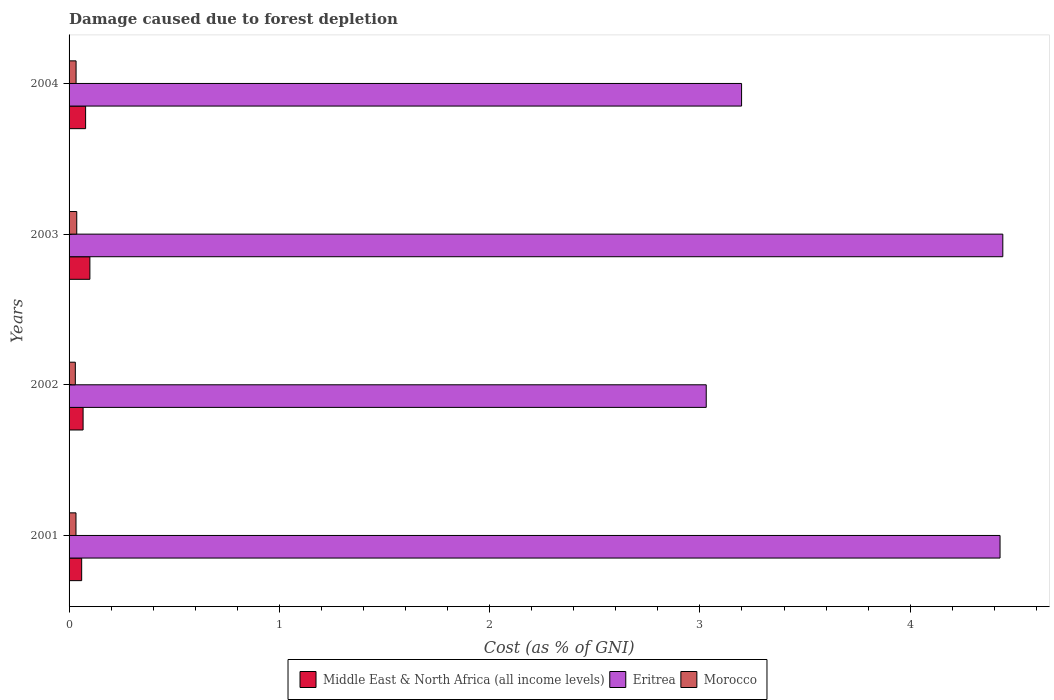How many groups of bars are there?
Offer a terse response. 4. Are the number of bars per tick equal to the number of legend labels?
Provide a succinct answer. Yes. How many bars are there on the 3rd tick from the top?
Offer a very short reply. 3. How many bars are there on the 4th tick from the bottom?
Give a very brief answer. 3. What is the cost of damage caused due to forest depletion in Eritrea in 2001?
Provide a short and direct response. 4.43. Across all years, what is the maximum cost of damage caused due to forest depletion in Eritrea?
Offer a very short reply. 4.44. Across all years, what is the minimum cost of damage caused due to forest depletion in Eritrea?
Offer a terse response. 3.03. In which year was the cost of damage caused due to forest depletion in Middle East & North Africa (all income levels) maximum?
Your response must be concise. 2003. What is the total cost of damage caused due to forest depletion in Middle East & North Africa (all income levels) in the graph?
Your response must be concise. 0.3. What is the difference between the cost of damage caused due to forest depletion in Middle East & North Africa (all income levels) in 2001 and that in 2004?
Provide a short and direct response. -0.02. What is the difference between the cost of damage caused due to forest depletion in Morocco in 2004 and the cost of damage caused due to forest depletion in Middle East & North Africa (all income levels) in 2002?
Provide a short and direct response. -0.03. What is the average cost of damage caused due to forest depletion in Eritrea per year?
Your answer should be very brief. 3.77. In the year 2002, what is the difference between the cost of damage caused due to forest depletion in Eritrea and cost of damage caused due to forest depletion in Middle East & North Africa (all income levels)?
Ensure brevity in your answer.  2.96. In how many years, is the cost of damage caused due to forest depletion in Middle East & North Africa (all income levels) greater than 1.2 %?
Keep it short and to the point. 0. What is the ratio of the cost of damage caused due to forest depletion in Middle East & North Africa (all income levels) in 2002 to that in 2004?
Your answer should be compact. 0.85. Is the cost of damage caused due to forest depletion in Morocco in 2003 less than that in 2004?
Your response must be concise. No. What is the difference between the highest and the second highest cost of damage caused due to forest depletion in Eritrea?
Ensure brevity in your answer.  0.01. What is the difference between the highest and the lowest cost of damage caused due to forest depletion in Eritrea?
Ensure brevity in your answer.  1.41. Is the sum of the cost of damage caused due to forest depletion in Morocco in 2001 and 2003 greater than the maximum cost of damage caused due to forest depletion in Middle East & North Africa (all income levels) across all years?
Keep it short and to the point. No. What does the 2nd bar from the top in 2001 represents?
Your answer should be very brief. Eritrea. What does the 1st bar from the bottom in 2001 represents?
Your answer should be very brief. Middle East & North Africa (all income levels). Is it the case that in every year, the sum of the cost of damage caused due to forest depletion in Eritrea and cost of damage caused due to forest depletion in Morocco is greater than the cost of damage caused due to forest depletion in Middle East & North Africa (all income levels)?
Provide a short and direct response. Yes. Are all the bars in the graph horizontal?
Provide a short and direct response. Yes. How many years are there in the graph?
Ensure brevity in your answer.  4. What is the difference between two consecutive major ticks on the X-axis?
Your answer should be compact. 1. How many legend labels are there?
Your answer should be very brief. 3. How are the legend labels stacked?
Offer a terse response. Horizontal. What is the title of the graph?
Offer a terse response. Damage caused due to forest depletion. Does "Seychelles" appear as one of the legend labels in the graph?
Ensure brevity in your answer.  No. What is the label or title of the X-axis?
Offer a terse response. Cost (as % of GNI). What is the Cost (as % of GNI) of Middle East & North Africa (all income levels) in 2001?
Ensure brevity in your answer.  0.06. What is the Cost (as % of GNI) in Eritrea in 2001?
Your answer should be compact. 4.43. What is the Cost (as % of GNI) of Morocco in 2001?
Keep it short and to the point. 0.03. What is the Cost (as % of GNI) of Middle East & North Africa (all income levels) in 2002?
Your response must be concise. 0.07. What is the Cost (as % of GNI) in Eritrea in 2002?
Give a very brief answer. 3.03. What is the Cost (as % of GNI) in Morocco in 2002?
Provide a short and direct response. 0.03. What is the Cost (as % of GNI) of Middle East & North Africa (all income levels) in 2003?
Provide a succinct answer. 0.1. What is the Cost (as % of GNI) of Eritrea in 2003?
Offer a terse response. 4.44. What is the Cost (as % of GNI) of Morocco in 2003?
Make the answer very short. 0.04. What is the Cost (as % of GNI) of Middle East & North Africa (all income levels) in 2004?
Your response must be concise. 0.08. What is the Cost (as % of GNI) in Eritrea in 2004?
Your response must be concise. 3.2. What is the Cost (as % of GNI) of Morocco in 2004?
Provide a short and direct response. 0.03. Across all years, what is the maximum Cost (as % of GNI) of Middle East & North Africa (all income levels)?
Make the answer very short. 0.1. Across all years, what is the maximum Cost (as % of GNI) of Eritrea?
Provide a short and direct response. 4.44. Across all years, what is the maximum Cost (as % of GNI) of Morocco?
Offer a terse response. 0.04. Across all years, what is the minimum Cost (as % of GNI) in Middle East & North Africa (all income levels)?
Offer a very short reply. 0.06. Across all years, what is the minimum Cost (as % of GNI) in Eritrea?
Keep it short and to the point. 3.03. Across all years, what is the minimum Cost (as % of GNI) in Morocco?
Provide a succinct answer. 0.03. What is the total Cost (as % of GNI) of Middle East & North Africa (all income levels) in the graph?
Offer a very short reply. 0.3. What is the total Cost (as % of GNI) of Eritrea in the graph?
Give a very brief answer. 15.1. What is the total Cost (as % of GNI) of Morocco in the graph?
Provide a succinct answer. 0.13. What is the difference between the Cost (as % of GNI) of Middle East & North Africa (all income levels) in 2001 and that in 2002?
Offer a very short reply. -0.01. What is the difference between the Cost (as % of GNI) in Eritrea in 2001 and that in 2002?
Ensure brevity in your answer.  1.4. What is the difference between the Cost (as % of GNI) of Morocco in 2001 and that in 2002?
Your answer should be very brief. 0. What is the difference between the Cost (as % of GNI) in Middle East & North Africa (all income levels) in 2001 and that in 2003?
Provide a short and direct response. -0.04. What is the difference between the Cost (as % of GNI) of Eritrea in 2001 and that in 2003?
Make the answer very short. -0.01. What is the difference between the Cost (as % of GNI) in Morocco in 2001 and that in 2003?
Your answer should be compact. -0. What is the difference between the Cost (as % of GNI) of Middle East & North Africa (all income levels) in 2001 and that in 2004?
Provide a succinct answer. -0.02. What is the difference between the Cost (as % of GNI) of Eritrea in 2001 and that in 2004?
Offer a terse response. 1.23. What is the difference between the Cost (as % of GNI) of Morocco in 2001 and that in 2004?
Provide a succinct answer. -0. What is the difference between the Cost (as % of GNI) of Middle East & North Africa (all income levels) in 2002 and that in 2003?
Ensure brevity in your answer.  -0.03. What is the difference between the Cost (as % of GNI) of Eritrea in 2002 and that in 2003?
Offer a terse response. -1.41. What is the difference between the Cost (as % of GNI) of Morocco in 2002 and that in 2003?
Provide a short and direct response. -0.01. What is the difference between the Cost (as % of GNI) of Middle East & North Africa (all income levels) in 2002 and that in 2004?
Your answer should be very brief. -0.01. What is the difference between the Cost (as % of GNI) of Eritrea in 2002 and that in 2004?
Your response must be concise. -0.17. What is the difference between the Cost (as % of GNI) in Morocco in 2002 and that in 2004?
Offer a terse response. -0. What is the difference between the Cost (as % of GNI) of Middle East & North Africa (all income levels) in 2003 and that in 2004?
Your answer should be very brief. 0.02. What is the difference between the Cost (as % of GNI) of Eritrea in 2003 and that in 2004?
Offer a terse response. 1.24. What is the difference between the Cost (as % of GNI) in Morocco in 2003 and that in 2004?
Your response must be concise. 0. What is the difference between the Cost (as % of GNI) of Middle East & North Africa (all income levels) in 2001 and the Cost (as % of GNI) of Eritrea in 2002?
Provide a short and direct response. -2.97. What is the difference between the Cost (as % of GNI) in Middle East & North Africa (all income levels) in 2001 and the Cost (as % of GNI) in Morocco in 2002?
Provide a succinct answer. 0.03. What is the difference between the Cost (as % of GNI) of Eritrea in 2001 and the Cost (as % of GNI) of Morocco in 2002?
Provide a succinct answer. 4.4. What is the difference between the Cost (as % of GNI) of Middle East & North Africa (all income levels) in 2001 and the Cost (as % of GNI) of Eritrea in 2003?
Offer a very short reply. -4.38. What is the difference between the Cost (as % of GNI) in Middle East & North Africa (all income levels) in 2001 and the Cost (as % of GNI) in Morocco in 2003?
Keep it short and to the point. 0.02. What is the difference between the Cost (as % of GNI) of Eritrea in 2001 and the Cost (as % of GNI) of Morocco in 2003?
Make the answer very short. 4.39. What is the difference between the Cost (as % of GNI) in Middle East & North Africa (all income levels) in 2001 and the Cost (as % of GNI) in Eritrea in 2004?
Provide a succinct answer. -3.14. What is the difference between the Cost (as % of GNI) of Middle East & North Africa (all income levels) in 2001 and the Cost (as % of GNI) of Morocco in 2004?
Make the answer very short. 0.03. What is the difference between the Cost (as % of GNI) in Eritrea in 2001 and the Cost (as % of GNI) in Morocco in 2004?
Provide a short and direct response. 4.39. What is the difference between the Cost (as % of GNI) of Middle East & North Africa (all income levels) in 2002 and the Cost (as % of GNI) of Eritrea in 2003?
Give a very brief answer. -4.37. What is the difference between the Cost (as % of GNI) of Middle East & North Africa (all income levels) in 2002 and the Cost (as % of GNI) of Morocco in 2003?
Make the answer very short. 0.03. What is the difference between the Cost (as % of GNI) of Eritrea in 2002 and the Cost (as % of GNI) of Morocco in 2003?
Your response must be concise. 2.99. What is the difference between the Cost (as % of GNI) in Middle East & North Africa (all income levels) in 2002 and the Cost (as % of GNI) in Eritrea in 2004?
Ensure brevity in your answer.  -3.13. What is the difference between the Cost (as % of GNI) of Middle East & North Africa (all income levels) in 2002 and the Cost (as % of GNI) of Morocco in 2004?
Offer a very short reply. 0.03. What is the difference between the Cost (as % of GNI) of Eritrea in 2002 and the Cost (as % of GNI) of Morocco in 2004?
Provide a short and direct response. 3. What is the difference between the Cost (as % of GNI) of Middle East & North Africa (all income levels) in 2003 and the Cost (as % of GNI) of Eritrea in 2004?
Your answer should be compact. -3.1. What is the difference between the Cost (as % of GNI) in Middle East & North Africa (all income levels) in 2003 and the Cost (as % of GNI) in Morocco in 2004?
Your answer should be compact. 0.07. What is the difference between the Cost (as % of GNI) in Eritrea in 2003 and the Cost (as % of GNI) in Morocco in 2004?
Offer a very short reply. 4.41. What is the average Cost (as % of GNI) of Middle East & North Africa (all income levels) per year?
Your answer should be very brief. 0.08. What is the average Cost (as % of GNI) in Eritrea per year?
Keep it short and to the point. 3.77. What is the average Cost (as % of GNI) in Morocco per year?
Keep it short and to the point. 0.03. In the year 2001, what is the difference between the Cost (as % of GNI) of Middle East & North Africa (all income levels) and Cost (as % of GNI) of Eritrea?
Keep it short and to the point. -4.37. In the year 2001, what is the difference between the Cost (as % of GNI) in Middle East & North Africa (all income levels) and Cost (as % of GNI) in Morocco?
Ensure brevity in your answer.  0.03. In the year 2001, what is the difference between the Cost (as % of GNI) of Eritrea and Cost (as % of GNI) of Morocco?
Give a very brief answer. 4.39. In the year 2002, what is the difference between the Cost (as % of GNI) in Middle East & North Africa (all income levels) and Cost (as % of GNI) in Eritrea?
Make the answer very short. -2.96. In the year 2002, what is the difference between the Cost (as % of GNI) of Middle East & North Africa (all income levels) and Cost (as % of GNI) of Morocco?
Provide a short and direct response. 0.04. In the year 2002, what is the difference between the Cost (as % of GNI) of Eritrea and Cost (as % of GNI) of Morocco?
Provide a succinct answer. 3. In the year 2003, what is the difference between the Cost (as % of GNI) of Middle East & North Africa (all income levels) and Cost (as % of GNI) of Eritrea?
Offer a very short reply. -4.34. In the year 2003, what is the difference between the Cost (as % of GNI) in Middle East & North Africa (all income levels) and Cost (as % of GNI) in Morocco?
Offer a very short reply. 0.06. In the year 2003, what is the difference between the Cost (as % of GNI) in Eritrea and Cost (as % of GNI) in Morocco?
Make the answer very short. 4.4. In the year 2004, what is the difference between the Cost (as % of GNI) of Middle East & North Africa (all income levels) and Cost (as % of GNI) of Eritrea?
Your answer should be compact. -3.12. In the year 2004, what is the difference between the Cost (as % of GNI) of Middle East & North Africa (all income levels) and Cost (as % of GNI) of Morocco?
Ensure brevity in your answer.  0.05. In the year 2004, what is the difference between the Cost (as % of GNI) of Eritrea and Cost (as % of GNI) of Morocco?
Your answer should be compact. 3.16. What is the ratio of the Cost (as % of GNI) in Middle East & North Africa (all income levels) in 2001 to that in 2002?
Provide a succinct answer. 0.9. What is the ratio of the Cost (as % of GNI) in Eritrea in 2001 to that in 2002?
Provide a succinct answer. 1.46. What is the ratio of the Cost (as % of GNI) in Morocco in 2001 to that in 2002?
Provide a succinct answer. 1.1. What is the ratio of the Cost (as % of GNI) of Middle East & North Africa (all income levels) in 2001 to that in 2003?
Make the answer very short. 0.6. What is the ratio of the Cost (as % of GNI) of Morocco in 2001 to that in 2003?
Offer a very short reply. 0.9. What is the ratio of the Cost (as % of GNI) of Middle East & North Africa (all income levels) in 2001 to that in 2004?
Offer a very short reply. 0.76. What is the ratio of the Cost (as % of GNI) in Eritrea in 2001 to that in 2004?
Your answer should be very brief. 1.38. What is the ratio of the Cost (as % of GNI) of Morocco in 2001 to that in 2004?
Make the answer very short. 0.99. What is the ratio of the Cost (as % of GNI) in Middle East & North Africa (all income levels) in 2002 to that in 2003?
Offer a terse response. 0.67. What is the ratio of the Cost (as % of GNI) of Eritrea in 2002 to that in 2003?
Provide a short and direct response. 0.68. What is the ratio of the Cost (as % of GNI) of Morocco in 2002 to that in 2003?
Give a very brief answer. 0.82. What is the ratio of the Cost (as % of GNI) in Middle East & North Africa (all income levels) in 2002 to that in 2004?
Provide a short and direct response. 0.85. What is the ratio of the Cost (as % of GNI) of Eritrea in 2002 to that in 2004?
Give a very brief answer. 0.95. What is the ratio of the Cost (as % of GNI) in Morocco in 2002 to that in 2004?
Make the answer very short. 0.89. What is the ratio of the Cost (as % of GNI) of Middle East & North Africa (all income levels) in 2003 to that in 2004?
Your answer should be compact. 1.26. What is the ratio of the Cost (as % of GNI) of Eritrea in 2003 to that in 2004?
Offer a very short reply. 1.39. What is the ratio of the Cost (as % of GNI) in Morocco in 2003 to that in 2004?
Keep it short and to the point. 1.1. What is the difference between the highest and the second highest Cost (as % of GNI) of Middle East & North Africa (all income levels)?
Make the answer very short. 0.02. What is the difference between the highest and the second highest Cost (as % of GNI) of Eritrea?
Your answer should be very brief. 0.01. What is the difference between the highest and the second highest Cost (as % of GNI) in Morocco?
Give a very brief answer. 0. What is the difference between the highest and the lowest Cost (as % of GNI) of Middle East & North Africa (all income levels)?
Ensure brevity in your answer.  0.04. What is the difference between the highest and the lowest Cost (as % of GNI) of Eritrea?
Your answer should be compact. 1.41. What is the difference between the highest and the lowest Cost (as % of GNI) in Morocco?
Offer a terse response. 0.01. 